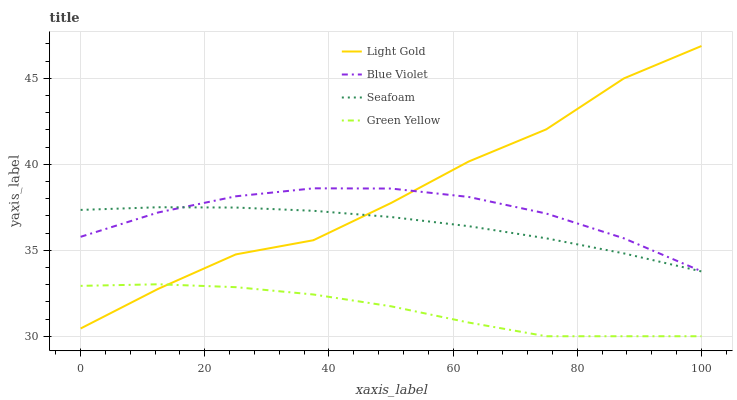Does Green Yellow have the minimum area under the curve?
Answer yes or no. Yes. Does Light Gold have the maximum area under the curve?
Answer yes or no. Yes. Does Seafoam have the minimum area under the curve?
Answer yes or no. No. Does Seafoam have the maximum area under the curve?
Answer yes or no. No. Is Seafoam the smoothest?
Answer yes or no. Yes. Is Light Gold the roughest?
Answer yes or no. Yes. Is Light Gold the smoothest?
Answer yes or no. No. Is Seafoam the roughest?
Answer yes or no. No. Does Green Yellow have the lowest value?
Answer yes or no. Yes. Does Light Gold have the lowest value?
Answer yes or no. No. Does Light Gold have the highest value?
Answer yes or no. Yes. Does Seafoam have the highest value?
Answer yes or no. No. Is Green Yellow less than Blue Violet?
Answer yes or no. Yes. Is Blue Violet greater than Green Yellow?
Answer yes or no. Yes. Does Blue Violet intersect Seafoam?
Answer yes or no. Yes. Is Blue Violet less than Seafoam?
Answer yes or no. No. Is Blue Violet greater than Seafoam?
Answer yes or no. No. Does Green Yellow intersect Blue Violet?
Answer yes or no. No. 